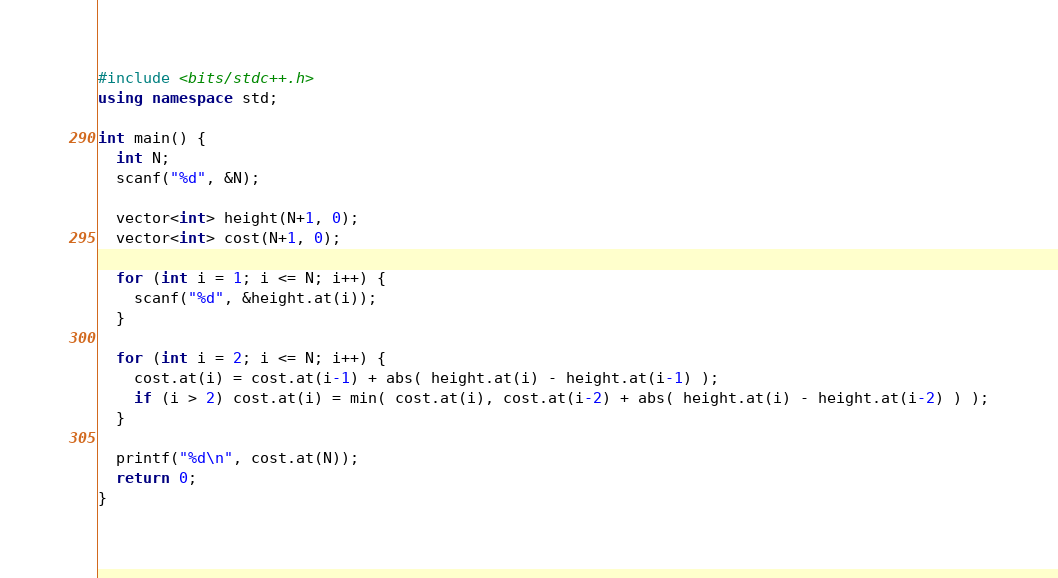<code> <loc_0><loc_0><loc_500><loc_500><_C++_>#include <bits/stdc++.h>
using namespace std;

int main() {
  int N;
  scanf("%d", &N);

  vector<int> height(N+1, 0);
  vector<int> cost(N+1, 0);

  for (int i = 1; i <= N; i++) {
    scanf("%d", &height.at(i));
  }

  for (int i = 2; i <= N; i++) {
    cost.at(i) = cost.at(i-1) + abs( height.at(i) - height.at(i-1) );
    if (i > 2) cost.at(i) = min( cost.at(i), cost.at(i-2) + abs( height.at(i) - height.at(i-2) ) );
  }

  printf("%d\n", cost.at(N));
  return 0;
}</code> 